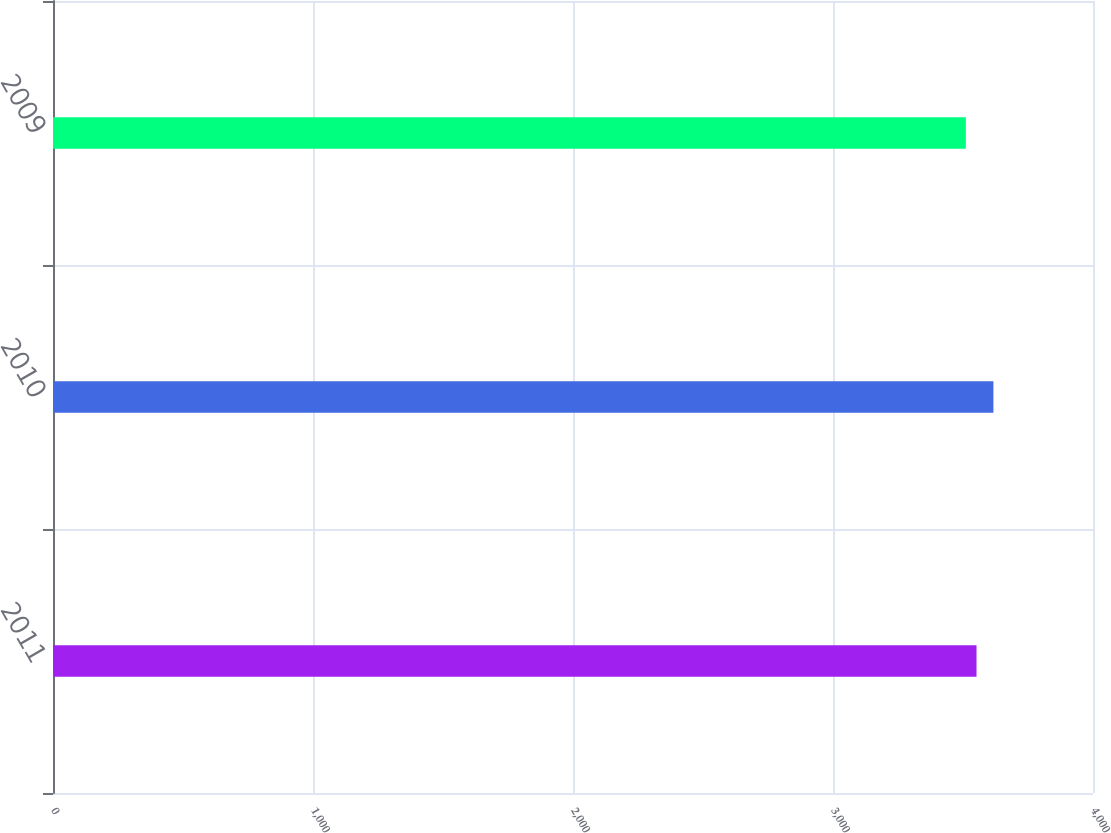Convert chart. <chart><loc_0><loc_0><loc_500><loc_500><bar_chart><fcel>2011<fcel>2010<fcel>2009<nl><fcel>3552<fcel>3617<fcel>3511<nl></chart> 